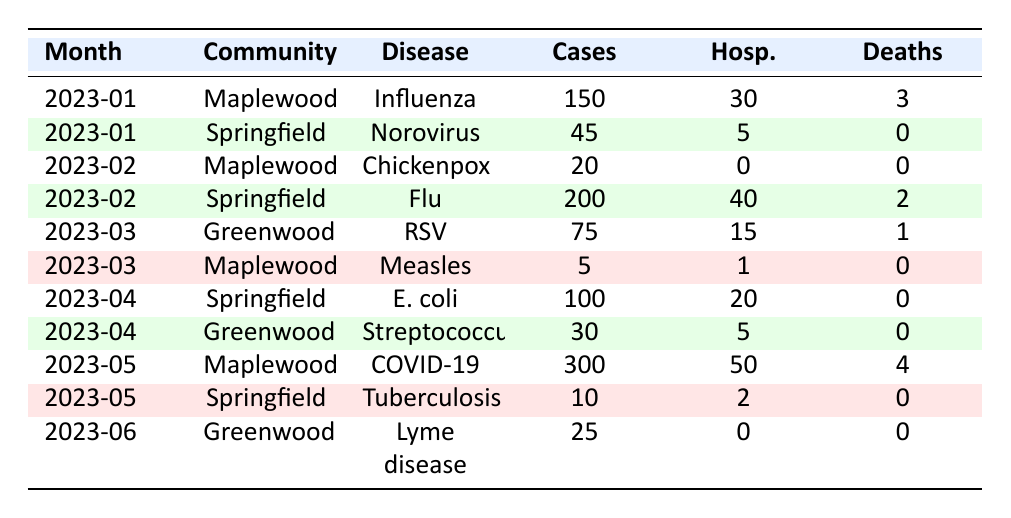What was the highest number of cases reported in a month? The highest single report of cases is from Maplewood in May 2023, with 300 cases of COVID-19.
Answer: 300 How many deaths were reported in Springfield in January 2023? In January 2023, Springfield reported 0 deaths due to Norovirus.
Answer: 0 Which community had the most hospitalizations in February 2023? Springfield had the most hospitalizations in February 2023, with 40 hospitalizations due to the flu.
Answer: Springfield What was the total number of cases reported across all communities in March 2023? Adding the cases from both Greenwood (75 cases of RSV) and Maplewood (5 cases of Measles), the total is 75 + 5 = 80 cases.
Answer: 80 How many deaths were reported from influenza in Maplewood in January 2023? In January 2023, Maplewood recorded 3 deaths from Influenza.
Answer: 3 Did Greenwood report any deaths from Lyme disease in June 2023? No, there were 0 deaths from Lyme disease reported in Greenwood in June 2023.
Answer: No What was the total number of hospitalizations in Springfield in April 2023? Springfield reported 20 hospitalizations from E. coli in April 2023.
Answer: 20 Which disease caused the highest number of hospitalizations in Maplewood? COVID-19 caused the highest number of hospitalizations in Maplewood, with 50 hospitalizations in May 2023.
Answer: COVID-19 Was there an outbreak of Chickenpox in March 2023? No, there was no outbreak of Chickenpox reported in March 2023; it was reported in February 2023.
Answer: No Calculate the average number of cases across all reported diseases in May 2023. In May 2023, Maplewood reported 300 cases of COVID-19 and Springfield reported 10 cases of Tuberculosis. The average is (300 + 10) / 2 = 155.
Answer: 155 